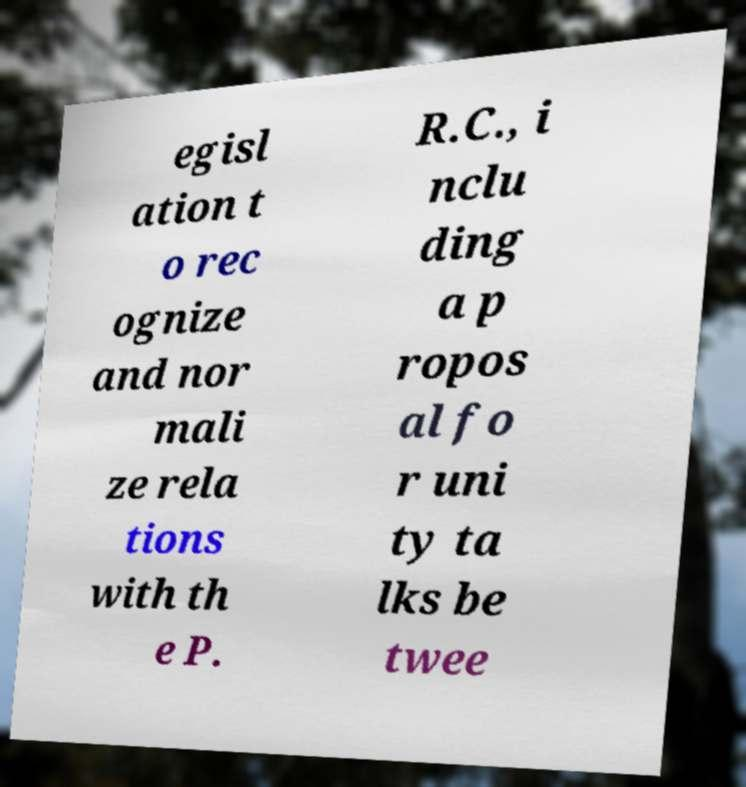What messages or text are displayed in this image? I need them in a readable, typed format. egisl ation t o rec ognize and nor mali ze rela tions with th e P. R.C., i nclu ding a p ropos al fo r uni ty ta lks be twee 